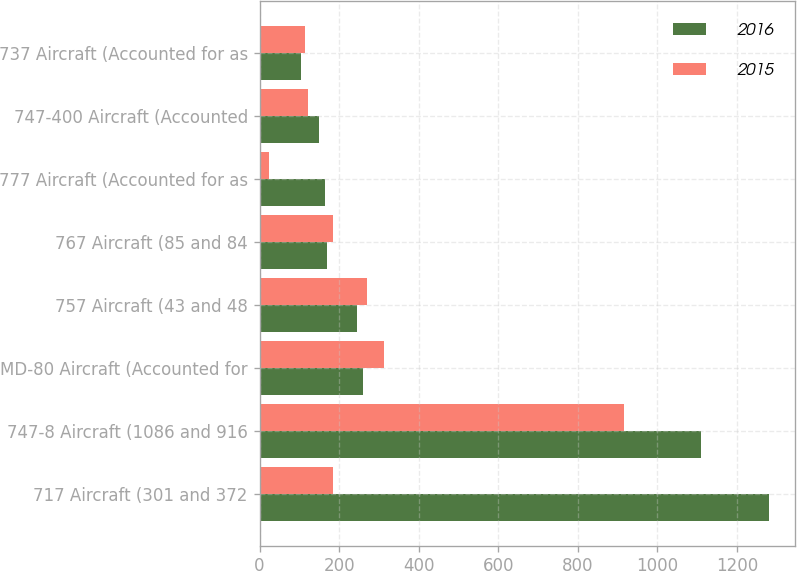Convert chart to OTSL. <chart><loc_0><loc_0><loc_500><loc_500><stacked_bar_chart><ecel><fcel>717 Aircraft (301 and 372<fcel>747-8 Aircraft (1086 and 916<fcel>MD-80 Aircraft (Accounted for<fcel>757 Aircraft (43 and 48<fcel>767 Aircraft (85 and 84<fcel>777 Aircraft (Accounted for as<fcel>747-400 Aircraft (Accounted<fcel>737 Aircraft (Accounted for as<nl><fcel>2016<fcel>1282<fcel>1111<fcel>259<fcel>246<fcel>170<fcel>165<fcel>149<fcel>103<nl><fcel>2015<fcel>185<fcel>916<fcel>314<fcel>270<fcel>185<fcel>23<fcel>122<fcel>115<nl></chart> 